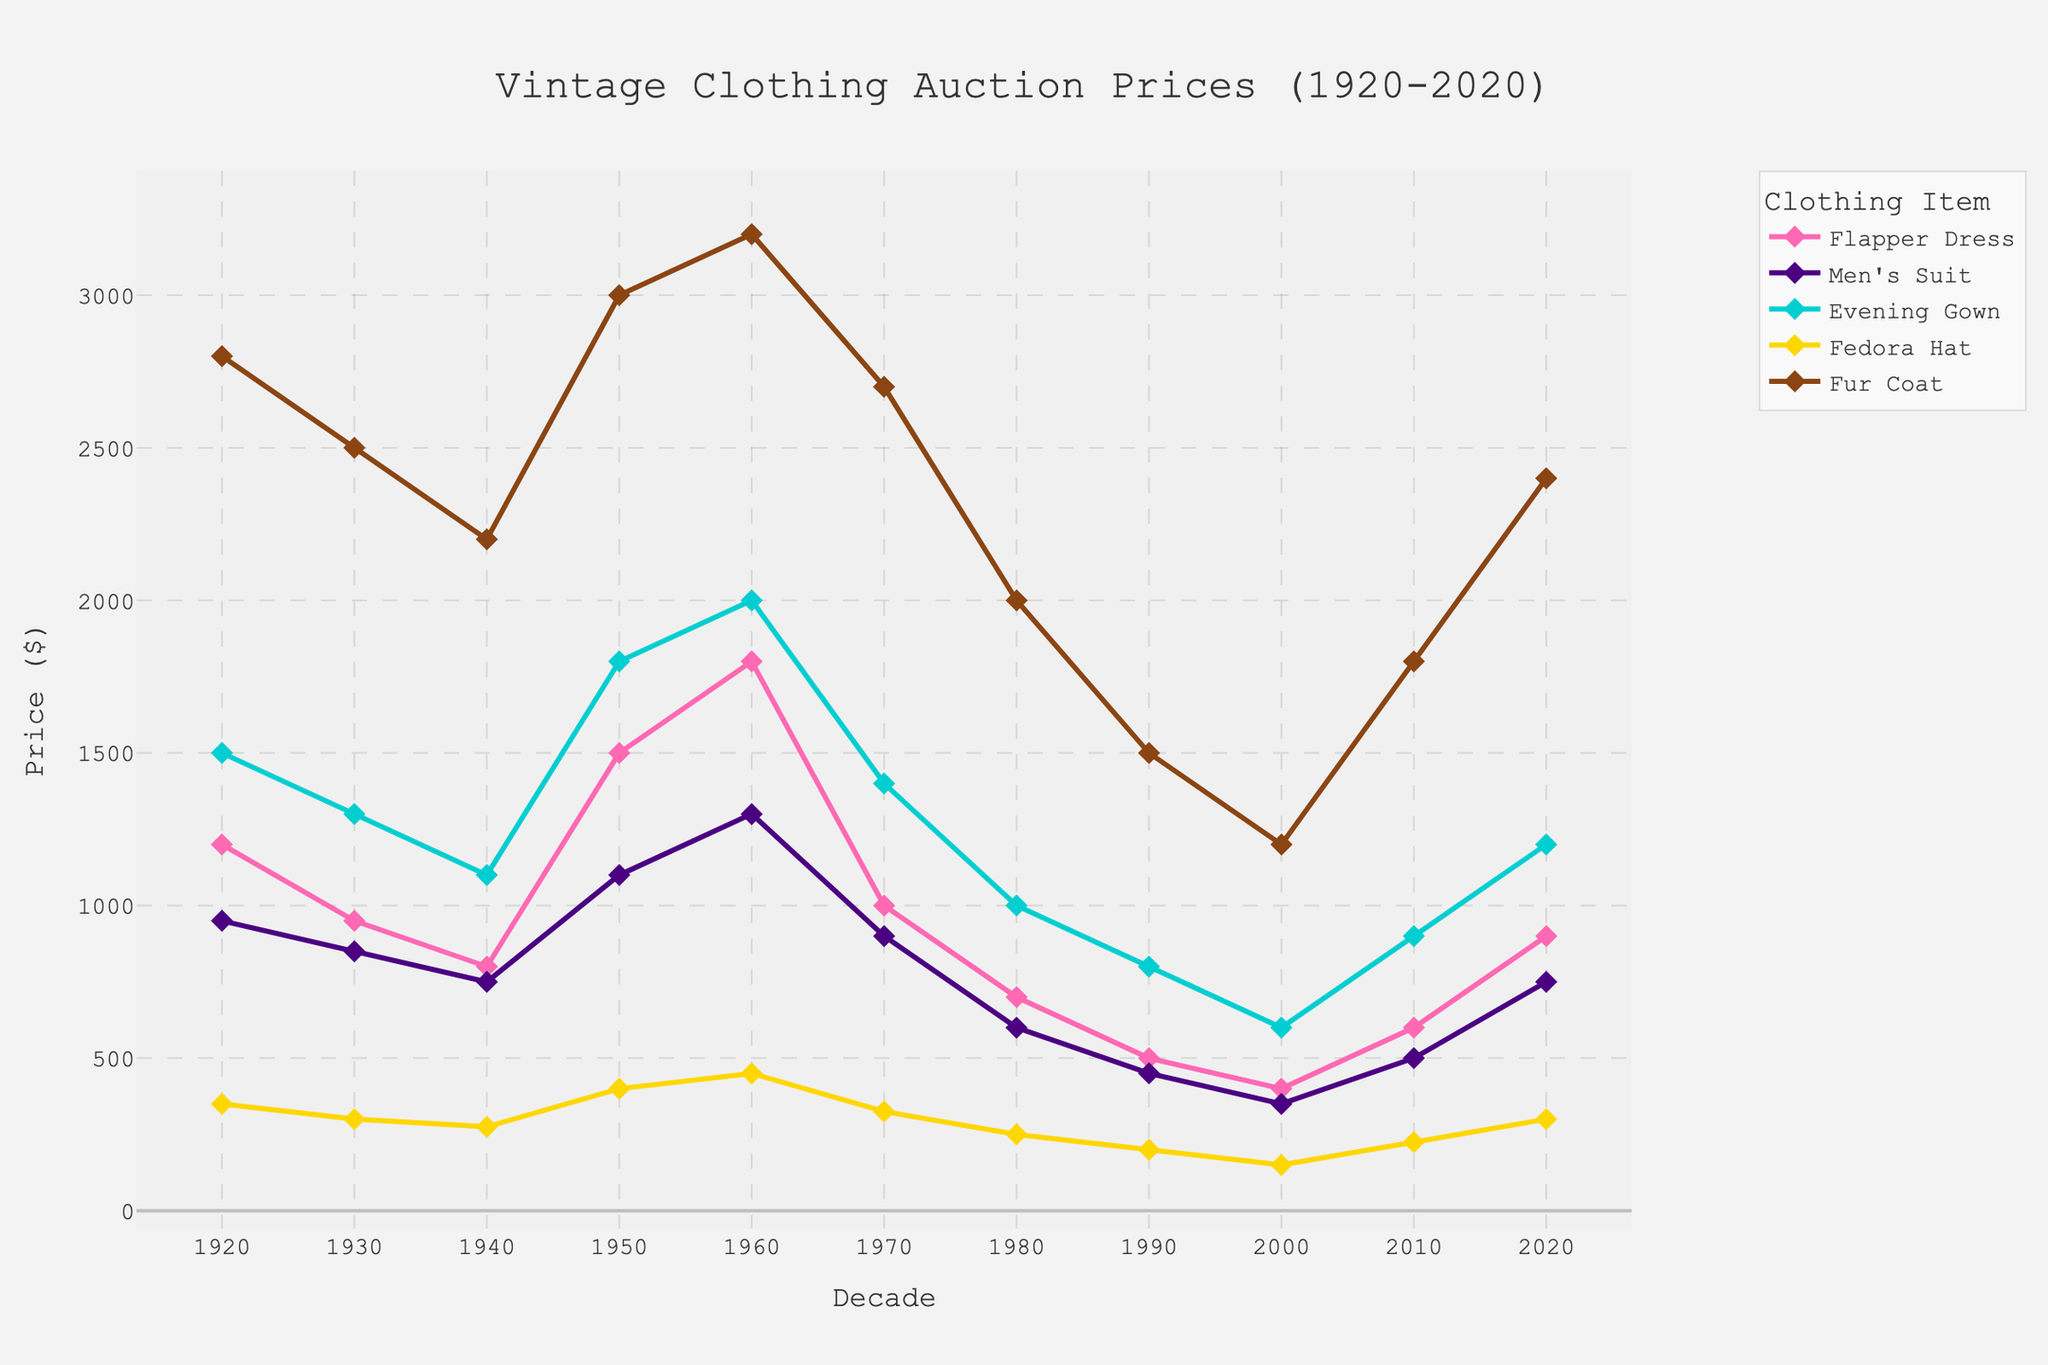Which decade had the highest average auction price for Flapper Dresses? To find the highest auction price for Flapper Dresses, I check each decade's price. The values are: 1920s ($1200), 1930s ($950), 1940s ($800), 1950s ($1500), 1960s ($1800), 1970s ($1000), 1980s ($700), 1990s ($500), 2000s ($400), 2010s ($600), 2020s ($900). The 1960s have the highest price at $1800.
Answer: 1960s How does the price of Fedora Hats in the 2020s compare to the 1920s? Check the auction prices for Fedora Hats in the 1920s ($350) and 2020s ($300). The 2020s price is lower than the 1920s.
Answer: Lower What is the overall trend in the auction price of Fur Coats from 1920 to 2020? Look at the prices for Fur Coats across all decades: 1920s ($2800), 1930s ($2500), 1940s ($2200), 1950s ($3000), 1960s ($3200), 1970s ($2700), 1980s ($2000), 1990s ($1500), 2000s ($1200), 2010s ($1800), 2020s ($2400). The prices generally decrease until the 2000s, then slightly increase.
Answer: Decline then rise Which item had the lowest auction price in the 1980s? Compare the auction prices of all items in the 1980s: Flapper Dress ($700), Men's Suit ($600), Evening Gown ($1000), Fedora Hat ($250), Fur Coat ($2000). The Fedora Hat is the lowest.
Answer: Fedora Hat By how much did the auction price of Men's Suits change from the 1950s to the 2020s? The price in the 1950s was $1100, and in the 2020s it is $750. The change is $1100 - $750 = $350.
Answer: $350 decrease What is the average auction price of Evening Gowns over all decades? Sum the prices of Evening Gowns across all decades: $1500 (1920s) + $1300 (1930s) + $1100 (1940s) + $1800 (1950s) + $2000 (1960s) + $1400 (1970s) + $1000 (1980s) + $800 (1990s) + $600 (2000s) + $900 (2010s) + $1200 (2020s) = $14600. There are 11 decades, so the average is $14600 / 11 = $1327.27.
Answer: $1327.27 Compare the price trend of Flapper Dresses and Men's Suits from 1920s to 2020s. Observe the prices of Flapper Dresses (1920s: $1200, 2020s: $900) and Men's Suits (1920s: $950, 2020s: $750). Both items show a fluctuating trend, but both follow a general decrease over the decades.
Answer: Both decrease overall 